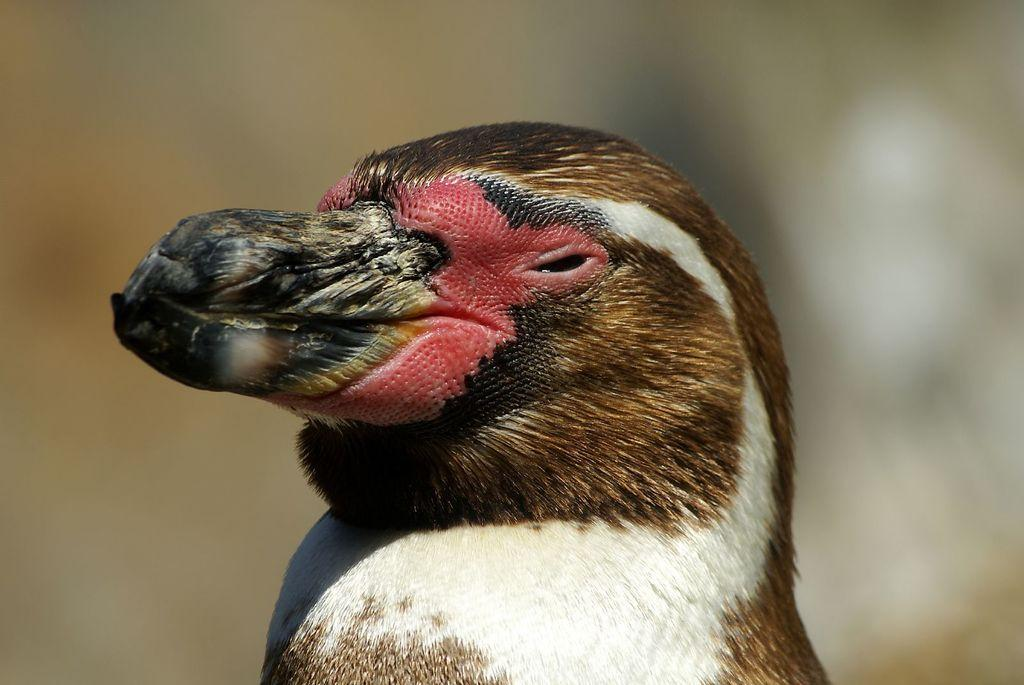What type of animal is in the image? There is a bird in the image. What colors can be seen on the bird? The bird has white, brown, red, and black colors. Can you describe the background of the image? The background of the image is blurred. What type of jeans is the bird wearing in the image? There are no jeans present in the image, as the bird is an animal and does not wear clothing. 